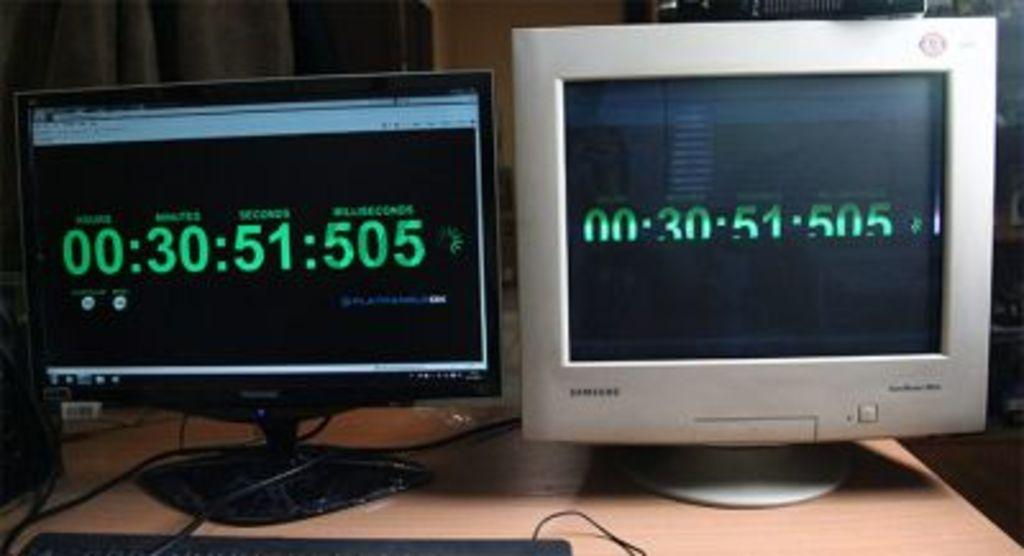<image>
Share a concise interpretation of the image provided. The digital display on two side by side monitors both read 00:30:51:505. 